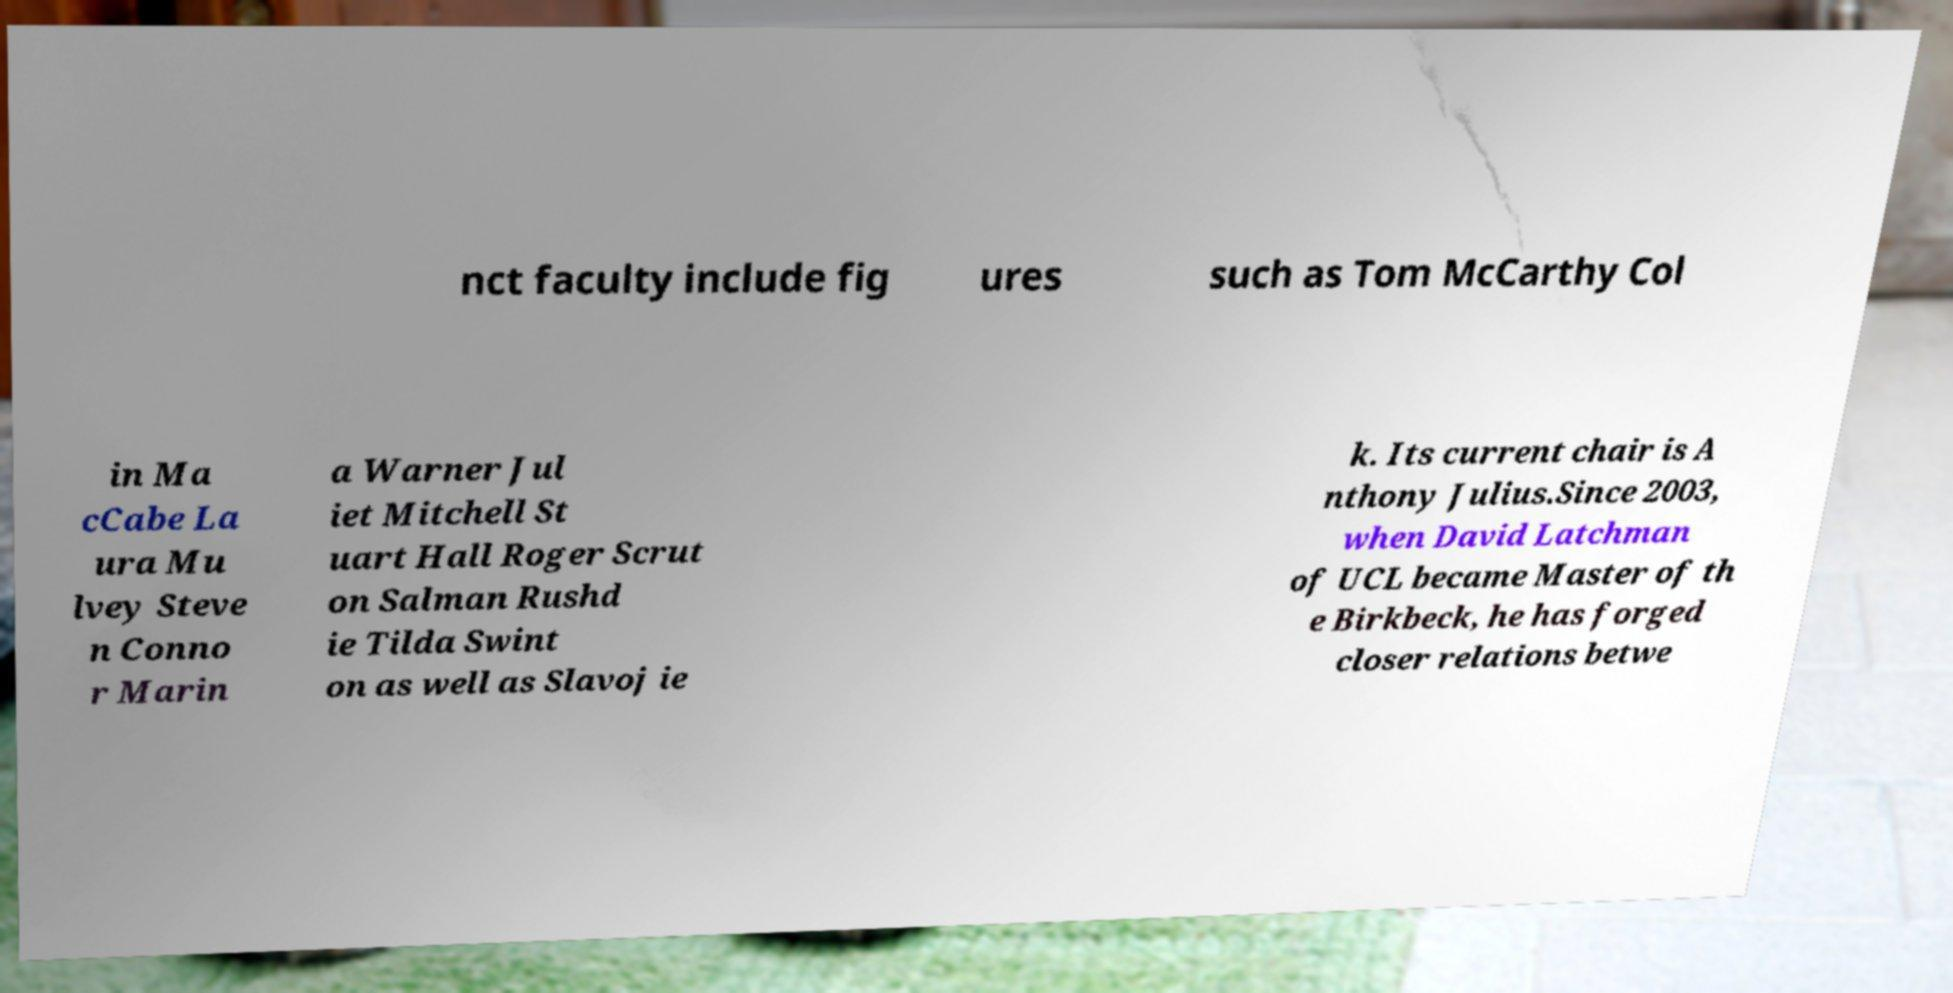There's text embedded in this image that I need extracted. Can you transcribe it verbatim? nct faculty include fig ures such as Tom McCarthy Col in Ma cCabe La ura Mu lvey Steve n Conno r Marin a Warner Jul iet Mitchell St uart Hall Roger Scrut on Salman Rushd ie Tilda Swint on as well as Slavoj ie k. Its current chair is A nthony Julius.Since 2003, when David Latchman of UCL became Master of th e Birkbeck, he has forged closer relations betwe 